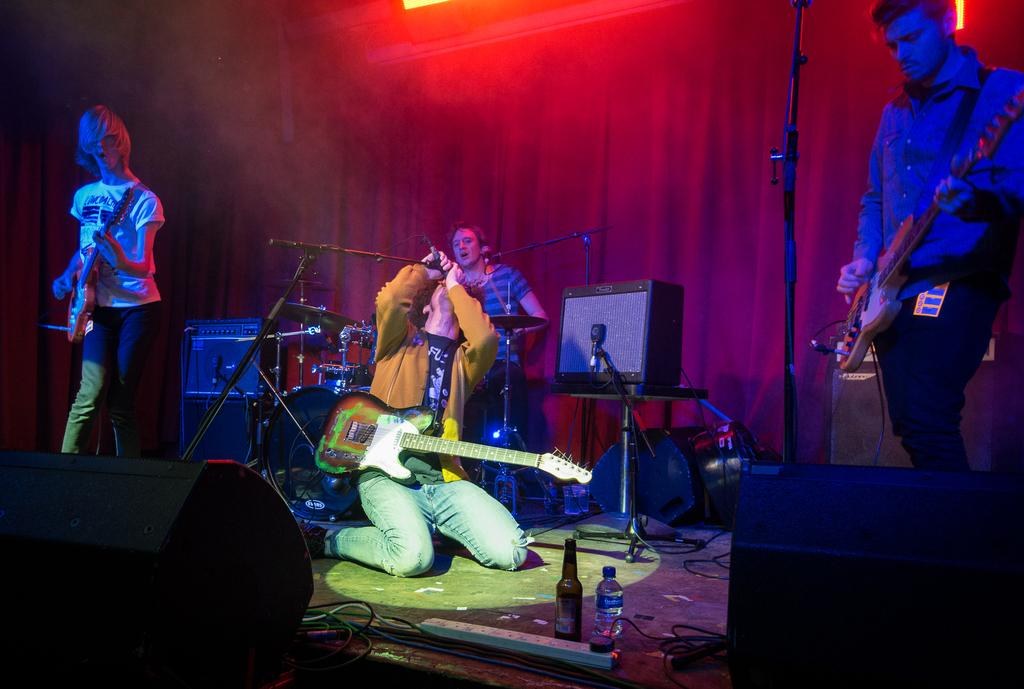Who or what can be seen in the image? There are people in the image. What are the people doing in the image? The people are playing musical instruments. Where are the people located in the image? The people are on a stage. What type of cactus can be seen on the stage in the image? There is no cactus present on the stage in the image. 